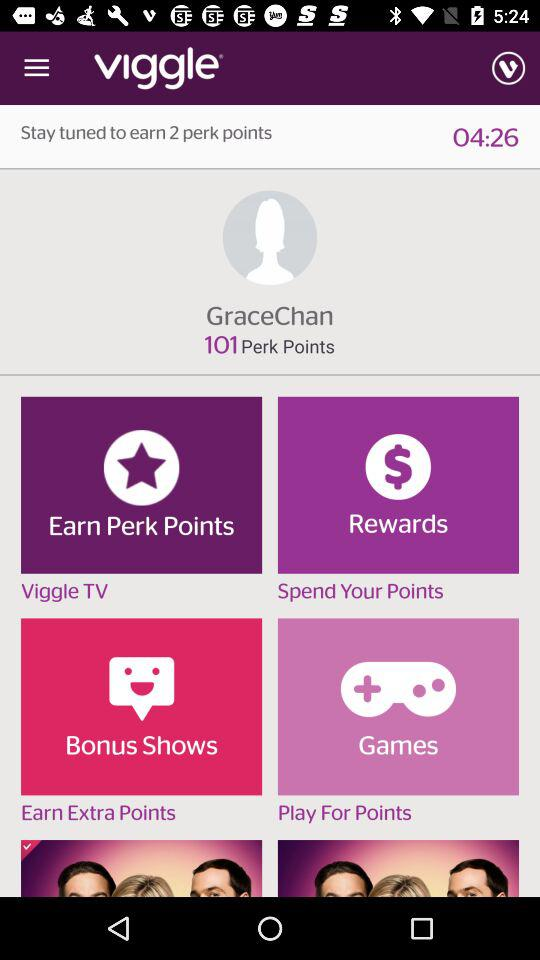What is the user name? The user name is Grace Chan. 